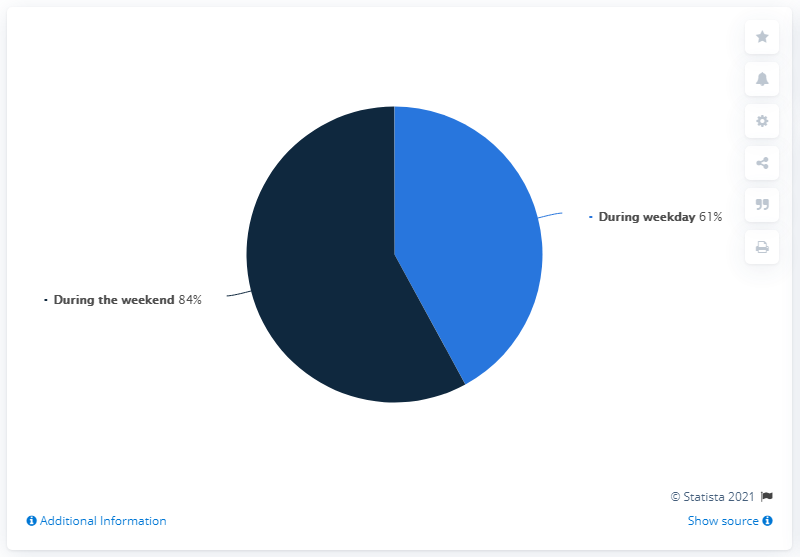Specify some key components in this picture. The most popular time in the chart is during the weekend. The ratio of weekend to weekday is 1.37704918... 